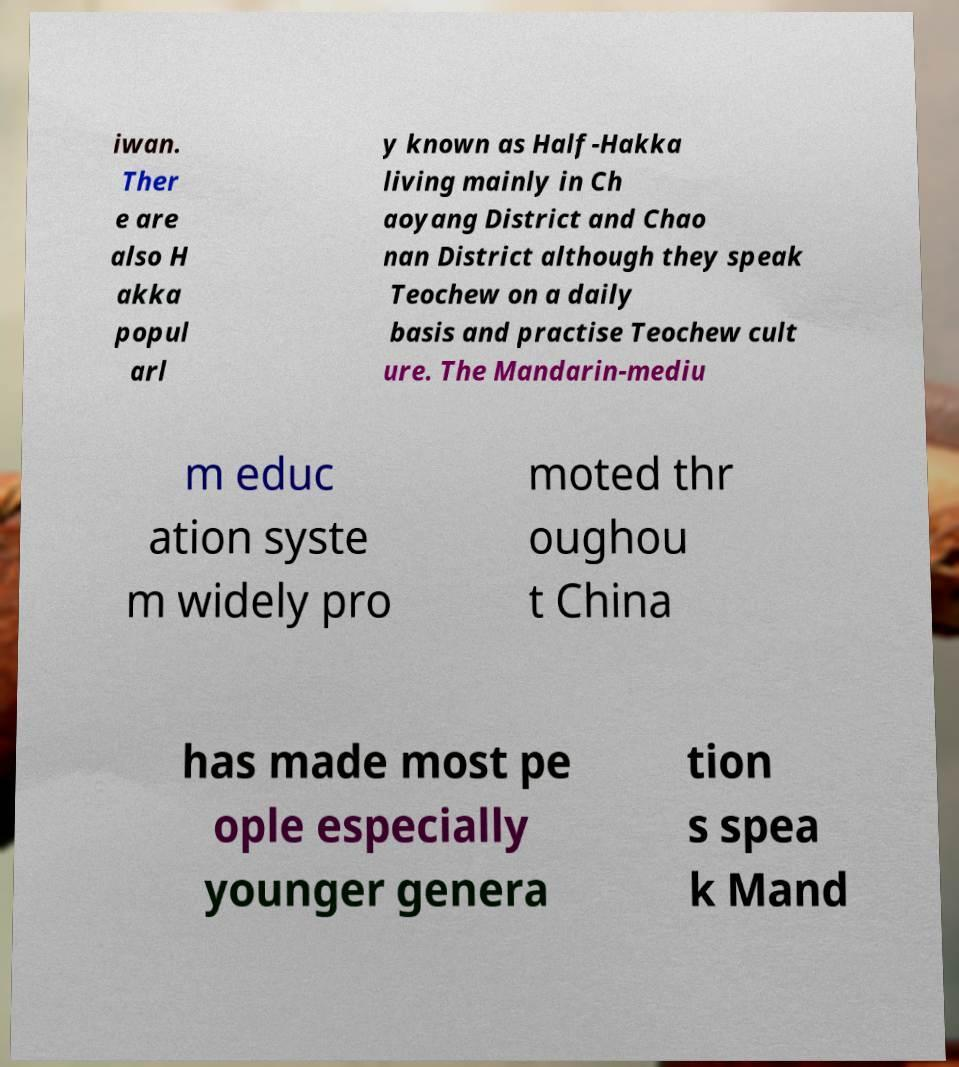Could you extract and type out the text from this image? iwan. Ther e are also H akka popul arl y known as Half-Hakka living mainly in Ch aoyang District and Chao nan District although they speak Teochew on a daily basis and practise Teochew cult ure. The Mandarin-mediu m educ ation syste m widely pro moted thr oughou t China has made most pe ople especially younger genera tion s spea k Mand 